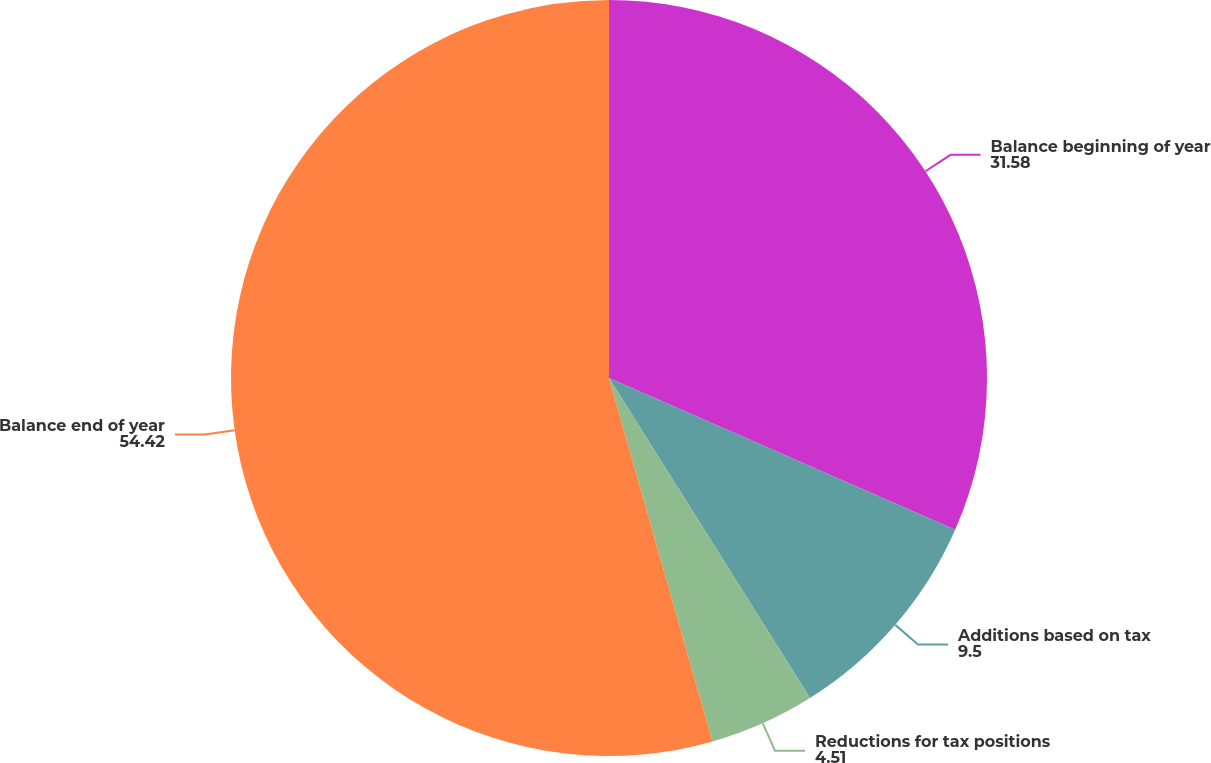Convert chart. <chart><loc_0><loc_0><loc_500><loc_500><pie_chart><fcel>Balance beginning of year<fcel>Additions based on tax<fcel>Reductions for tax positions<fcel>Balance end of year<nl><fcel>31.58%<fcel>9.5%<fcel>4.51%<fcel>54.42%<nl></chart> 